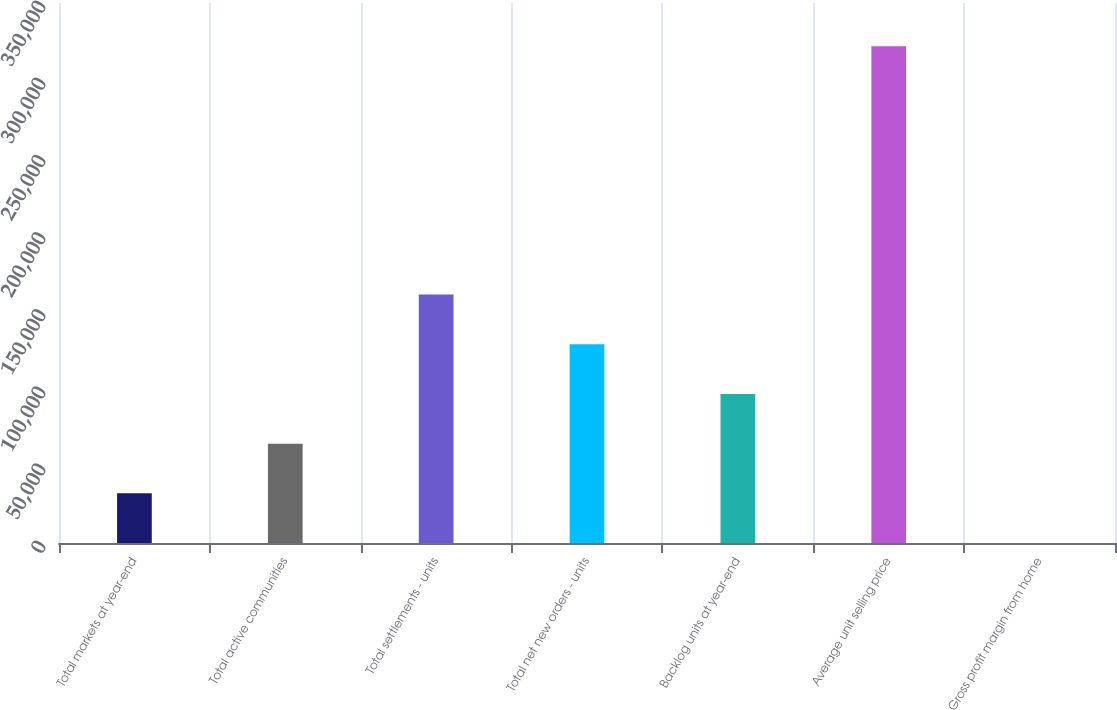Convert chart. <chart><loc_0><loc_0><loc_500><loc_500><bar_chart><fcel>Total markets at year-end<fcel>Total active communities<fcel>Total settlements - units<fcel>Total net new orders - units<fcel>Backlog units at year-end<fcel>Average unit selling price<fcel>Gross profit margin from home<nl><fcel>32204.5<fcel>64404<fcel>161002<fcel>128803<fcel>96603.5<fcel>322000<fcel>5<nl></chart> 